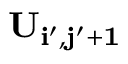<formula> <loc_0><loc_0><loc_500><loc_500>U _ { i ^ { \prime } , j ^ { \prime } + 1 }</formula> 